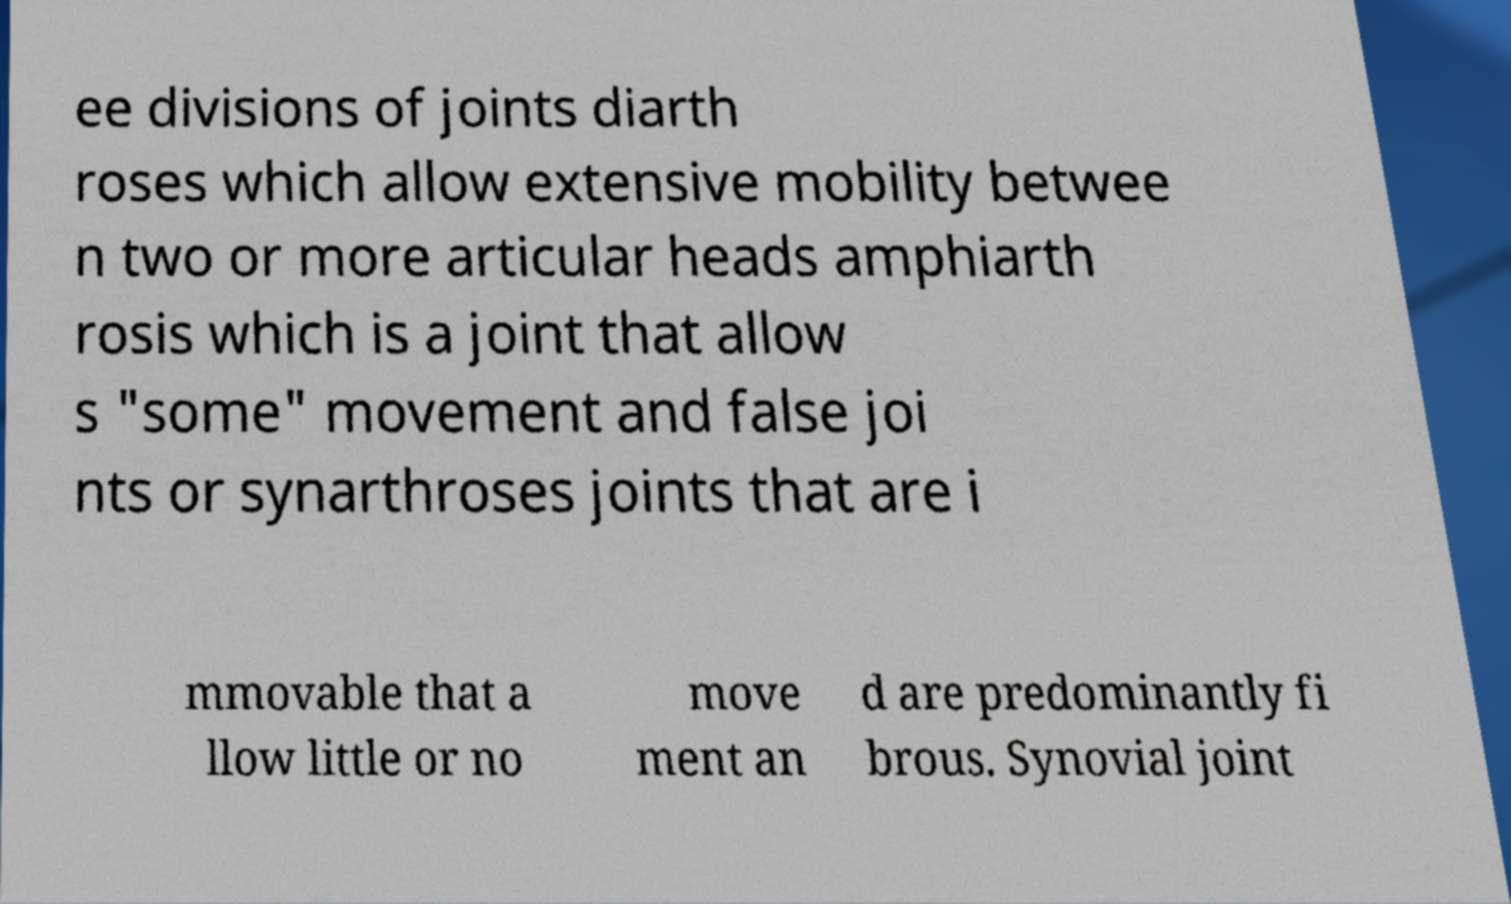Please read and relay the text visible in this image. What does it say? ee divisions of joints diarth roses which allow extensive mobility betwee n two or more articular heads amphiarth rosis which is a joint that allow s "some" movement and false joi nts or synarthroses joints that are i mmovable that a llow little or no move ment an d are predominantly fi brous. Synovial joint 